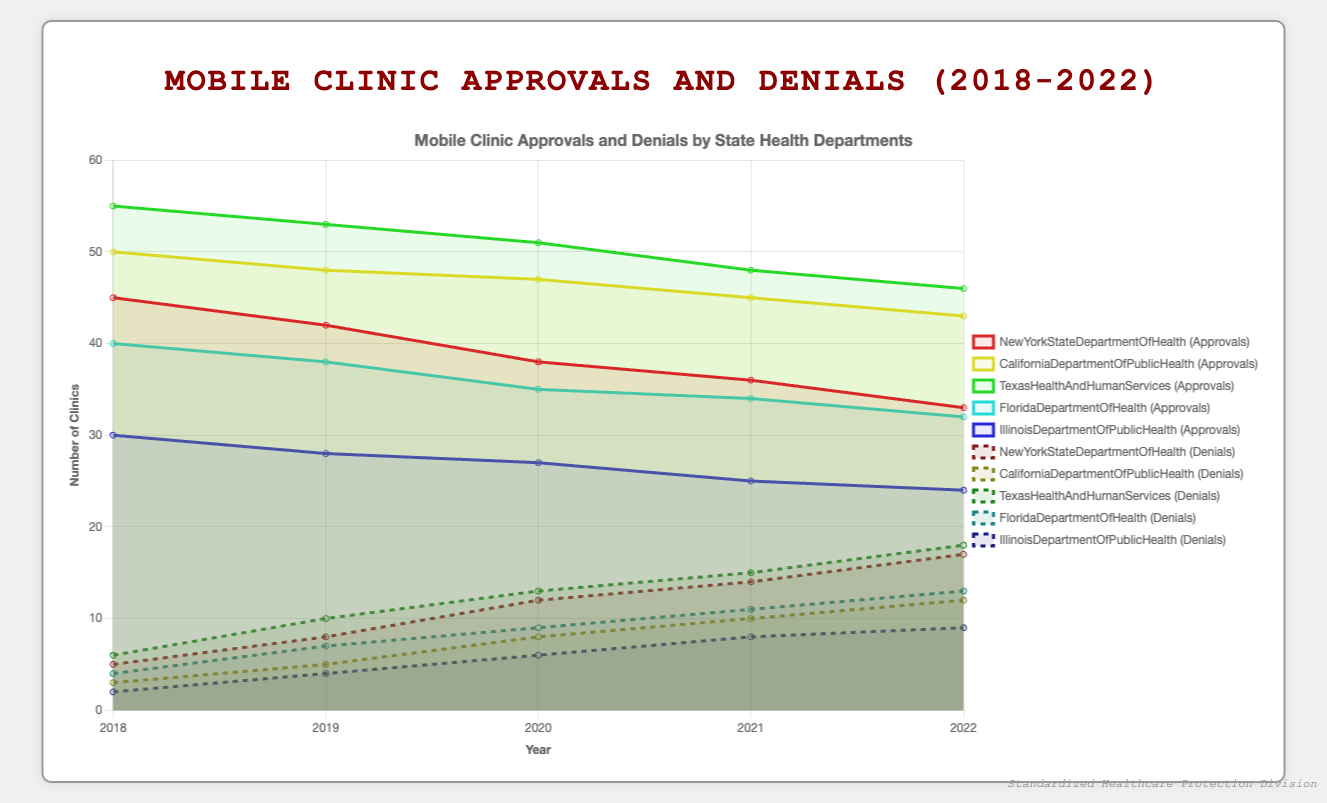What is the trend in approvals for New York State Department of Health over the past five years? The line plot shows the number of mobile clinic approvals by the New York State Department of Health. From 2018 to 2022, the approval numbers have steadily declined from 45 in 2018 to 33 in 2022.
Answer: The trend is downward How do the mobile clinic denials in Texas compare to those in California for the year 2022? Looking at 2022 in the line plot, Texas had 18 denials while California had 12. Therefore, Texas had higher denial numbers compared to California in 2022.
Answer: Texas had more denials Which state had the most notable decrease in approvals from 2018 to 2022? By analyzing the downward slopes in the approval lines, New York State Department of Health shows a sharp decrease from 45 to 33, indicating a reduction of 12 approvals. This compares more significantly against other states.
Answer: New York State Sum up the approvals for Illinois Department of Public Health for the years 2019 and 2020. In 2019, Illinois had 28 approvals and in 2020, it had 27. Adding these two values together gives us 28 + 27 = 55.
Answer: 55 What is the average number of mobile clinic denials in Florida over the past five years? The denial numbers for Florida from 2018 to 2022 are 4, 7, 9, 11, 13. Summing these gives a total of 44. Dividing by 5 (the number of years) results in an average of 44/5 = 8.8.
Answer: 8.8 Compare the trends of approvals and denials for Texas Health and Human Services between 2020-2022. From 2020 to 2022, Texas approvals decrease from 51 to 46, while denials increase from 13 to 18. This indicates an inverse relationship where approvals are declining while denials are rising during this period.
Answer: Approvals decreased; Denials increased Which state had the smallest absolute change in the number of approvals from 2018 to 2022? Illinois Department of Public Health had the smallest change in approvals, going from 30 in 2018 to 24 in 2022, a change of 6 approvals.
Answer: Illinois Visually, which departmental line for approvals is the most stable (least fluctuating) over time? The line representing approvals by the California Department of Public Health shows the most stability as it has the least fluctuation, going from 50 to 43 gradually over five years.
Answer: California 